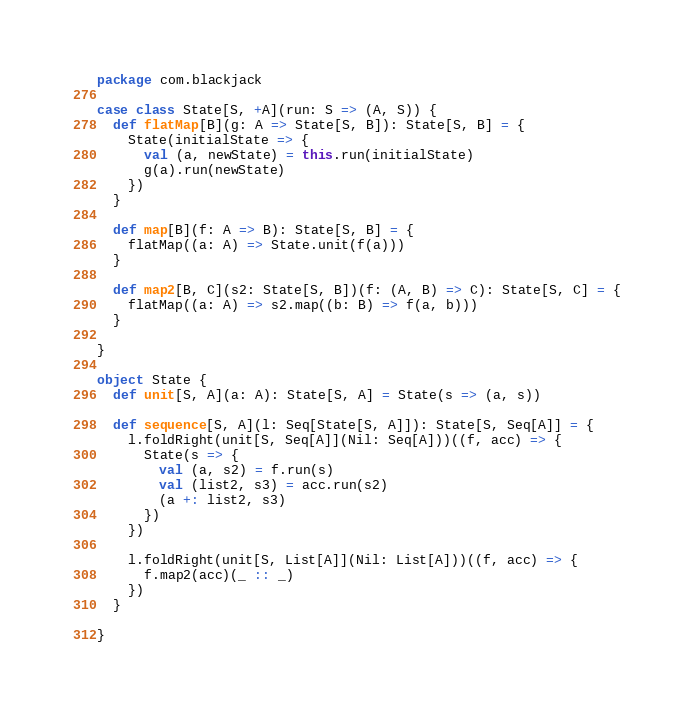Convert code to text. <code><loc_0><loc_0><loc_500><loc_500><_Scala_>package com.blackjack

case class State[S, +A](run: S => (A, S)) {
  def flatMap[B](g: A => State[S, B]): State[S, B] = {
    State(initialState => {
      val (a, newState) = this.run(initialState)
      g(a).run(newState)
    })
  }

  def map[B](f: A => B): State[S, B] = {
    flatMap((a: A) => State.unit(f(a)))
  }

  def map2[B, C](s2: State[S, B])(f: (A, B) => C): State[S, C] = {
    flatMap((a: A) => s2.map((b: B) => f(a, b)))
  }

}

object State {
  def unit[S, A](a: A): State[S, A] = State(s => (a, s))

  def sequence[S, A](l: Seq[State[S, A]]): State[S, Seq[A]] = {
    l.foldRight(unit[S, Seq[A]](Nil: Seq[A]))((f, acc) => {
      State(s => {
        val (a, s2) = f.run(s)
        val (list2, s3) = acc.run(s2)
        (a +: list2, s3)
      })
    })

    l.foldRight(unit[S, List[A]](Nil: List[A]))((f, acc) => {
      f.map2(acc)(_ :: _)
    })
  }

}
</code> 